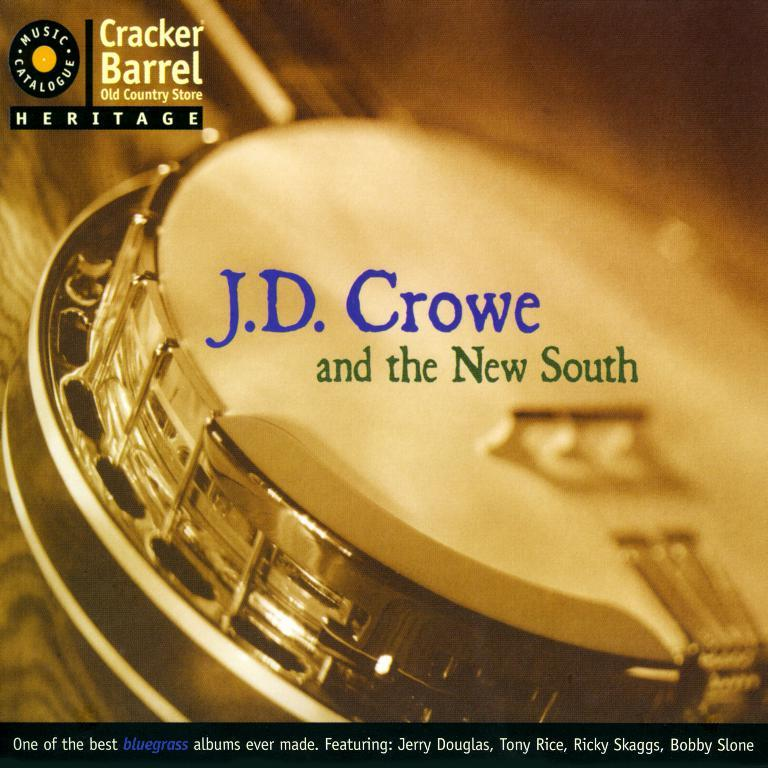<image>
Write a terse but informative summary of the picture. an album cover that says 'j.d. crowe and the new south' 